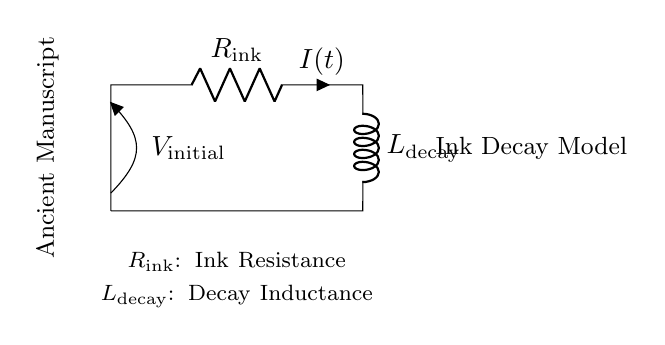What components are present in this circuit? The circuit contains a resistor labeled R_ink and an inductor labeled L_decay. These represent the ink resistance and decay inductance respectively.
Answer: Resistor, Inductor What does R_ink represent? R_ink illustrates the resistance associated with the ancient manuscript ink, indicating how it affects the decay process over time.
Answer: Ink Resistance What is the function of L_decay? L_decay signifies the inductance related to the decay of ink, influencing how the current changes through the circuit over time.
Answer: Decay Inductance What is the initial voltage in the circuit? The initial voltage is V_initial, as indicated by the voltage source labeled in the diagram, representing the starting voltage for the circuit.
Answer: V_initial Explain the relationship between resistance and current decay in this circuit. The resistance determines the rate at which current decreases in the RL circuit; with higher resistance, the current decays faster due to more energy being dissipated.
Answer: Higher resistance leads to faster current decay How does the combination of the resistor and inductor affect the decay of ink over time? The resistor and inductor together create an RL time constant that shapes the current decay curve, showing how ink fades over time through an exponential decay function.
Answer: Exponential decay What might a higher value of L_decay imply about ink decay? A higher L_decay value would suggest a slower rate of change in current within the circuit, indicating that the ink decay process would take longer over time.
Answer: Slower decay rate 